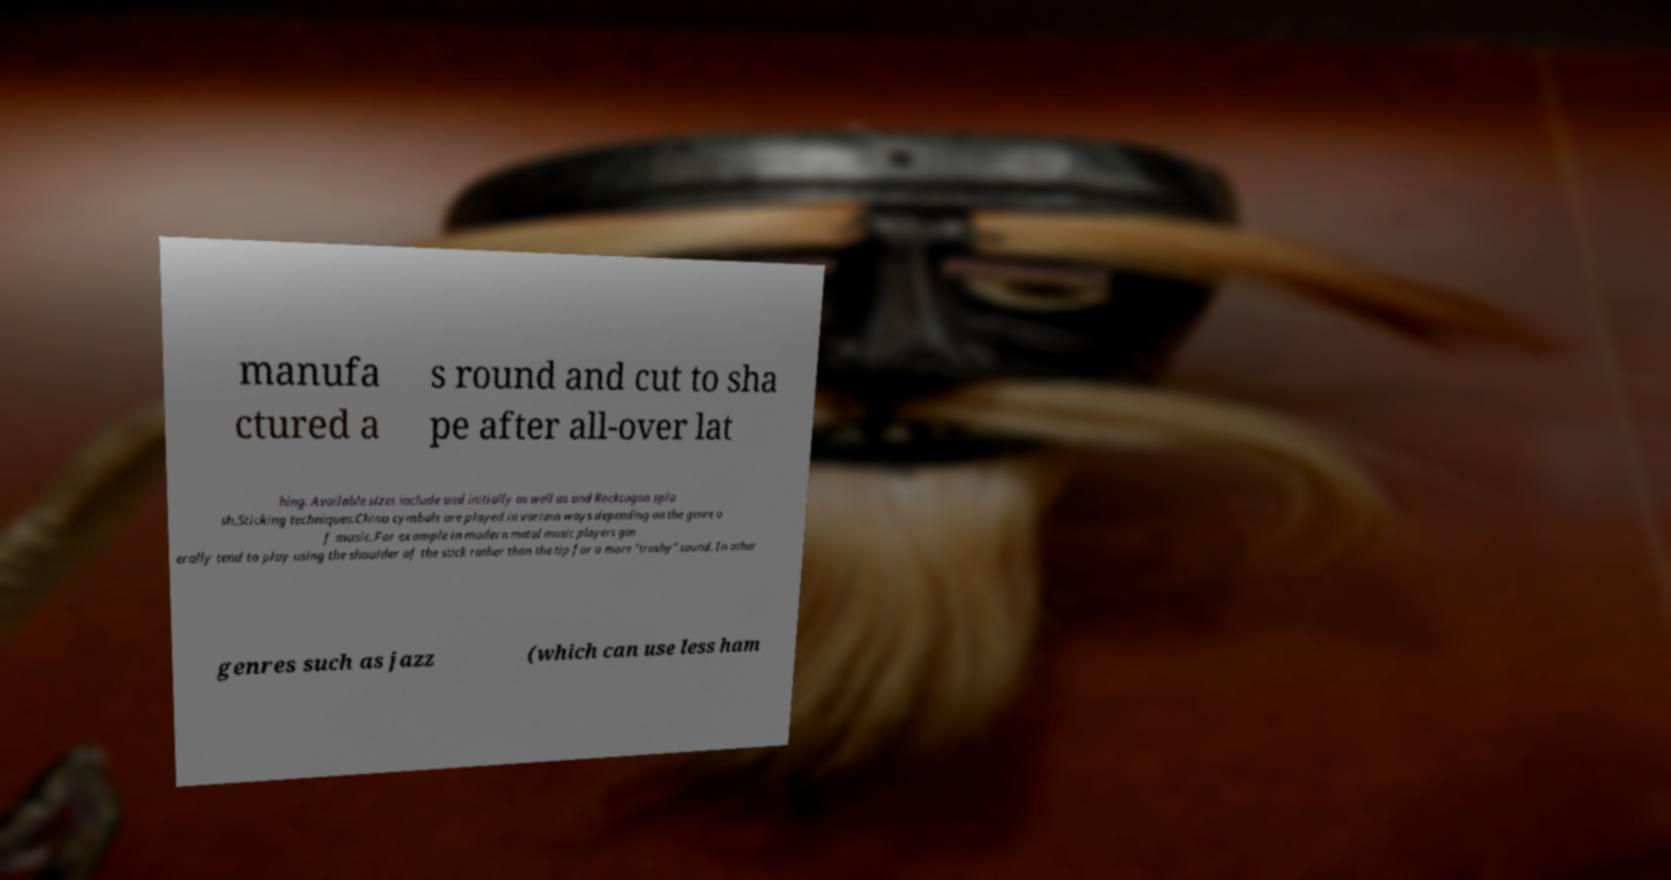Could you extract and type out the text from this image? manufa ctured a s round and cut to sha pe after all-over lat hing. Available sizes include and initially as well as and Rocktagon spla sh.Sticking techniques.China cymbals are played in various ways depending on the genre o f music.For example in modern metal music players gen erally tend to play using the shoulder of the stick rather than the tip for a more "trashy" sound. In other genres such as jazz (which can use less ham 